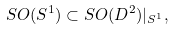Convert formula to latex. <formula><loc_0><loc_0><loc_500><loc_500>S O ( S ^ { 1 } ) \subset S O ( D ^ { 2 } ) | _ { S ^ { 1 } } ,</formula> 